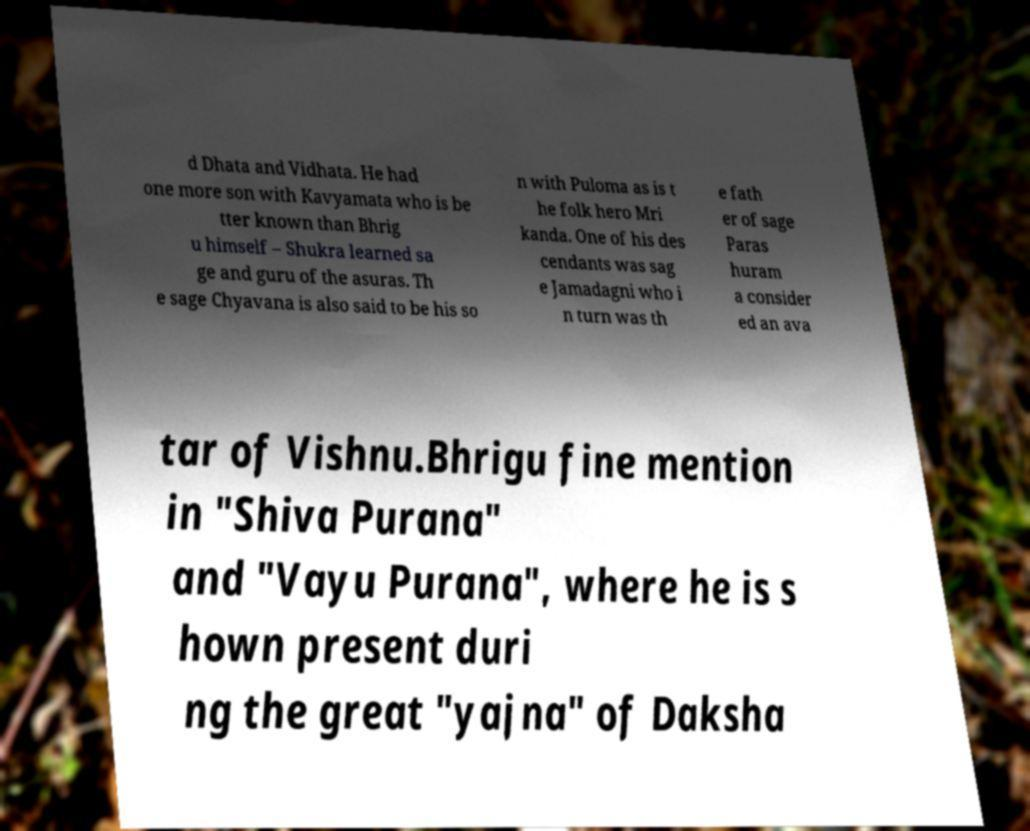Can you read and provide the text displayed in the image?This photo seems to have some interesting text. Can you extract and type it out for me? d Dhata and Vidhata. He had one more son with Kavyamata who is be tter known than Bhrig u himself – Shukra learned sa ge and guru of the asuras. Th e sage Chyavana is also said to be his so n with Puloma as is t he folk hero Mri kanda. One of his des cendants was sag e Jamadagni who i n turn was th e fath er of sage Paras huram a consider ed an ava tar of Vishnu.Bhrigu fine mention in "Shiva Purana" and "Vayu Purana", where he is s hown present duri ng the great "yajna" of Daksha 